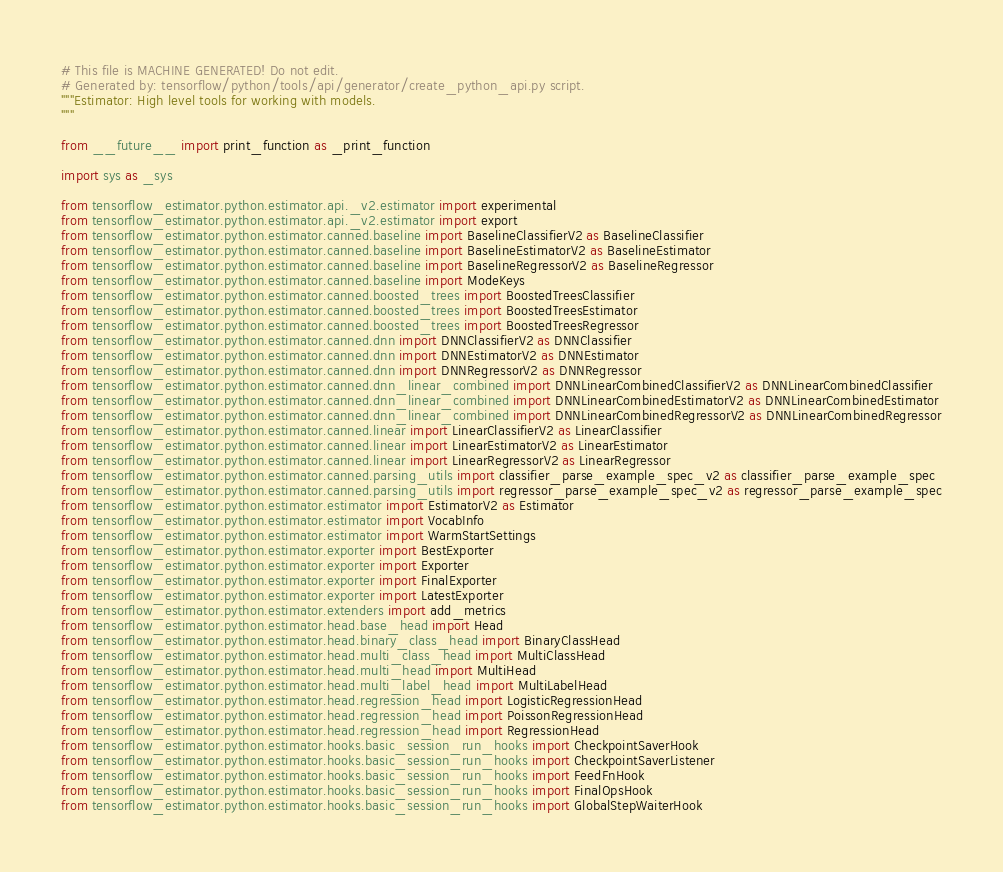<code> <loc_0><loc_0><loc_500><loc_500><_Python_># This file is MACHINE GENERATED! Do not edit.
# Generated by: tensorflow/python/tools/api/generator/create_python_api.py script.
"""Estimator: High level tools for working with models.
"""

from __future__ import print_function as _print_function

import sys as _sys

from tensorflow_estimator.python.estimator.api._v2.estimator import experimental
from tensorflow_estimator.python.estimator.api._v2.estimator import export
from tensorflow_estimator.python.estimator.canned.baseline import BaselineClassifierV2 as BaselineClassifier
from tensorflow_estimator.python.estimator.canned.baseline import BaselineEstimatorV2 as BaselineEstimator
from tensorflow_estimator.python.estimator.canned.baseline import BaselineRegressorV2 as BaselineRegressor
from tensorflow_estimator.python.estimator.canned.baseline import ModeKeys
from tensorflow_estimator.python.estimator.canned.boosted_trees import BoostedTreesClassifier
from tensorflow_estimator.python.estimator.canned.boosted_trees import BoostedTreesEstimator
from tensorflow_estimator.python.estimator.canned.boosted_trees import BoostedTreesRegressor
from tensorflow_estimator.python.estimator.canned.dnn import DNNClassifierV2 as DNNClassifier
from tensorflow_estimator.python.estimator.canned.dnn import DNNEstimatorV2 as DNNEstimator
from tensorflow_estimator.python.estimator.canned.dnn import DNNRegressorV2 as DNNRegressor
from tensorflow_estimator.python.estimator.canned.dnn_linear_combined import DNNLinearCombinedClassifierV2 as DNNLinearCombinedClassifier
from tensorflow_estimator.python.estimator.canned.dnn_linear_combined import DNNLinearCombinedEstimatorV2 as DNNLinearCombinedEstimator
from tensorflow_estimator.python.estimator.canned.dnn_linear_combined import DNNLinearCombinedRegressorV2 as DNNLinearCombinedRegressor
from tensorflow_estimator.python.estimator.canned.linear import LinearClassifierV2 as LinearClassifier
from tensorflow_estimator.python.estimator.canned.linear import LinearEstimatorV2 as LinearEstimator
from tensorflow_estimator.python.estimator.canned.linear import LinearRegressorV2 as LinearRegressor
from tensorflow_estimator.python.estimator.canned.parsing_utils import classifier_parse_example_spec_v2 as classifier_parse_example_spec
from tensorflow_estimator.python.estimator.canned.parsing_utils import regressor_parse_example_spec_v2 as regressor_parse_example_spec
from tensorflow_estimator.python.estimator.estimator import EstimatorV2 as Estimator
from tensorflow_estimator.python.estimator.estimator import VocabInfo
from tensorflow_estimator.python.estimator.estimator import WarmStartSettings
from tensorflow_estimator.python.estimator.exporter import BestExporter
from tensorflow_estimator.python.estimator.exporter import Exporter
from tensorflow_estimator.python.estimator.exporter import FinalExporter
from tensorflow_estimator.python.estimator.exporter import LatestExporter
from tensorflow_estimator.python.estimator.extenders import add_metrics
from tensorflow_estimator.python.estimator.head.base_head import Head
from tensorflow_estimator.python.estimator.head.binary_class_head import BinaryClassHead
from tensorflow_estimator.python.estimator.head.multi_class_head import MultiClassHead
from tensorflow_estimator.python.estimator.head.multi_head import MultiHead
from tensorflow_estimator.python.estimator.head.multi_label_head import MultiLabelHead
from tensorflow_estimator.python.estimator.head.regression_head import LogisticRegressionHead
from tensorflow_estimator.python.estimator.head.regression_head import PoissonRegressionHead
from tensorflow_estimator.python.estimator.head.regression_head import RegressionHead
from tensorflow_estimator.python.estimator.hooks.basic_session_run_hooks import CheckpointSaverHook
from tensorflow_estimator.python.estimator.hooks.basic_session_run_hooks import CheckpointSaverListener
from tensorflow_estimator.python.estimator.hooks.basic_session_run_hooks import FeedFnHook
from tensorflow_estimator.python.estimator.hooks.basic_session_run_hooks import FinalOpsHook
from tensorflow_estimator.python.estimator.hooks.basic_session_run_hooks import GlobalStepWaiterHook</code> 